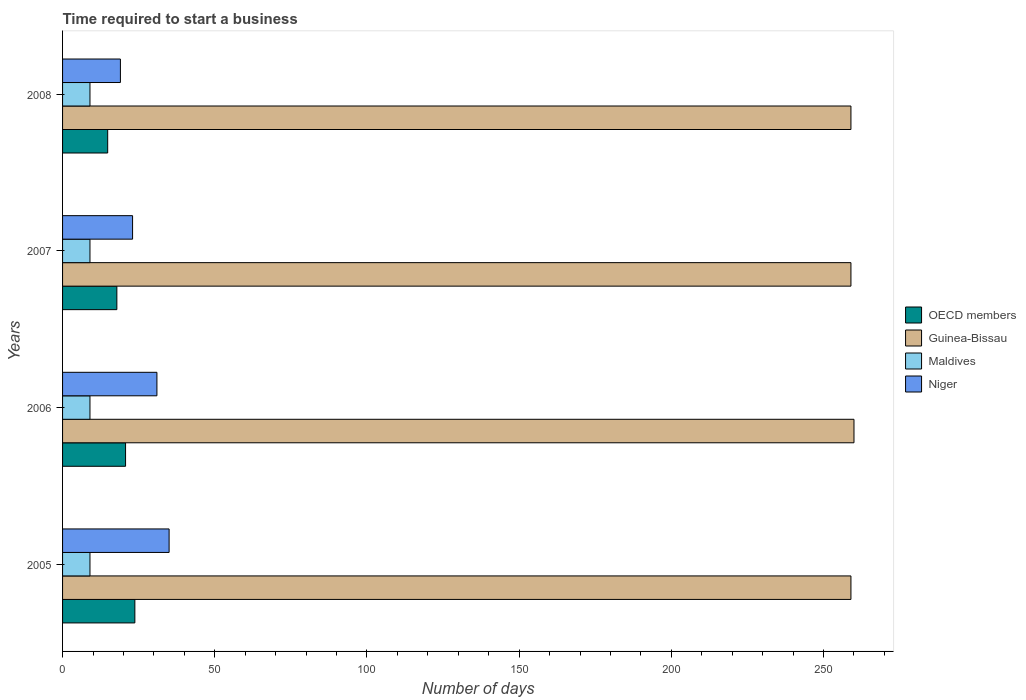How many groups of bars are there?
Provide a short and direct response. 4. Are the number of bars on each tick of the Y-axis equal?
Keep it short and to the point. Yes. How many bars are there on the 1st tick from the top?
Your answer should be compact. 4. What is the number of days required to start a business in Niger in 2008?
Your answer should be very brief. 19. Across all years, what is the maximum number of days required to start a business in OECD members?
Offer a terse response. 23.75. Across all years, what is the minimum number of days required to start a business in Niger?
Offer a very short reply. 19. In which year was the number of days required to start a business in Guinea-Bissau minimum?
Provide a succinct answer. 2005. What is the total number of days required to start a business in Maldives in the graph?
Your response must be concise. 36. What is the difference between the number of days required to start a business in Guinea-Bissau in 2005 and that in 2006?
Give a very brief answer. -1. What is the difference between the number of days required to start a business in Guinea-Bissau in 2005 and the number of days required to start a business in Maldives in 2008?
Provide a succinct answer. 250. In the year 2006, what is the difference between the number of days required to start a business in Niger and number of days required to start a business in Guinea-Bissau?
Your answer should be compact. -229. In how many years, is the number of days required to start a business in OECD members greater than 220 days?
Offer a terse response. 0. What is the ratio of the number of days required to start a business in Niger in 2006 to that in 2007?
Your answer should be compact. 1.35. What is the difference between the highest and the second highest number of days required to start a business in OECD members?
Offer a terse response. 3.06. Is it the case that in every year, the sum of the number of days required to start a business in Guinea-Bissau and number of days required to start a business in Niger is greater than the sum of number of days required to start a business in OECD members and number of days required to start a business in Maldives?
Offer a terse response. No. What does the 1st bar from the top in 2006 represents?
Offer a very short reply. Niger. What does the 3rd bar from the bottom in 2007 represents?
Give a very brief answer. Maldives. Is it the case that in every year, the sum of the number of days required to start a business in OECD members and number of days required to start a business in Maldives is greater than the number of days required to start a business in Guinea-Bissau?
Offer a very short reply. No. How many bars are there?
Your answer should be compact. 16. How many years are there in the graph?
Give a very brief answer. 4. Where does the legend appear in the graph?
Ensure brevity in your answer.  Center right. How are the legend labels stacked?
Keep it short and to the point. Vertical. What is the title of the graph?
Give a very brief answer. Time required to start a business. What is the label or title of the X-axis?
Offer a very short reply. Number of days. What is the Number of days in OECD members in 2005?
Your answer should be compact. 23.75. What is the Number of days of Guinea-Bissau in 2005?
Make the answer very short. 259. What is the Number of days in Maldives in 2005?
Offer a terse response. 9. What is the Number of days in OECD members in 2006?
Give a very brief answer. 20.69. What is the Number of days in Guinea-Bissau in 2006?
Make the answer very short. 260. What is the Number of days of Maldives in 2006?
Your answer should be compact. 9. What is the Number of days in OECD members in 2007?
Ensure brevity in your answer.  17.84. What is the Number of days in Guinea-Bissau in 2007?
Provide a short and direct response. 259. What is the Number of days of Niger in 2007?
Offer a very short reply. 23. What is the Number of days in OECD members in 2008?
Offer a terse response. 14.82. What is the Number of days in Guinea-Bissau in 2008?
Make the answer very short. 259. What is the Number of days of Maldives in 2008?
Keep it short and to the point. 9. What is the Number of days of Niger in 2008?
Make the answer very short. 19. Across all years, what is the maximum Number of days in OECD members?
Offer a terse response. 23.75. Across all years, what is the maximum Number of days in Guinea-Bissau?
Offer a terse response. 260. Across all years, what is the maximum Number of days of Niger?
Provide a succinct answer. 35. Across all years, what is the minimum Number of days of OECD members?
Give a very brief answer. 14.82. Across all years, what is the minimum Number of days of Guinea-Bissau?
Your response must be concise. 259. What is the total Number of days in OECD members in the graph?
Offer a very short reply. 77.1. What is the total Number of days in Guinea-Bissau in the graph?
Ensure brevity in your answer.  1037. What is the total Number of days in Niger in the graph?
Your response must be concise. 108. What is the difference between the Number of days in OECD members in 2005 and that in 2006?
Your answer should be very brief. 3.06. What is the difference between the Number of days of Guinea-Bissau in 2005 and that in 2006?
Keep it short and to the point. -1. What is the difference between the Number of days of Maldives in 2005 and that in 2006?
Provide a short and direct response. 0. What is the difference between the Number of days of Niger in 2005 and that in 2006?
Give a very brief answer. 4. What is the difference between the Number of days in OECD members in 2005 and that in 2007?
Provide a short and direct response. 5.91. What is the difference between the Number of days in Guinea-Bissau in 2005 and that in 2007?
Your response must be concise. 0. What is the difference between the Number of days in OECD members in 2005 and that in 2008?
Keep it short and to the point. 8.93. What is the difference between the Number of days in Guinea-Bissau in 2005 and that in 2008?
Provide a succinct answer. 0. What is the difference between the Number of days in Niger in 2005 and that in 2008?
Provide a short and direct response. 16. What is the difference between the Number of days of OECD members in 2006 and that in 2007?
Provide a short and direct response. 2.85. What is the difference between the Number of days of OECD members in 2006 and that in 2008?
Give a very brief answer. 5.87. What is the difference between the Number of days of OECD members in 2007 and that in 2008?
Provide a short and direct response. 3.02. What is the difference between the Number of days of Guinea-Bissau in 2007 and that in 2008?
Your answer should be compact. 0. What is the difference between the Number of days of OECD members in 2005 and the Number of days of Guinea-Bissau in 2006?
Provide a short and direct response. -236.25. What is the difference between the Number of days of OECD members in 2005 and the Number of days of Maldives in 2006?
Make the answer very short. 14.75. What is the difference between the Number of days of OECD members in 2005 and the Number of days of Niger in 2006?
Provide a short and direct response. -7.25. What is the difference between the Number of days of Guinea-Bissau in 2005 and the Number of days of Maldives in 2006?
Keep it short and to the point. 250. What is the difference between the Number of days in Guinea-Bissau in 2005 and the Number of days in Niger in 2006?
Provide a short and direct response. 228. What is the difference between the Number of days of OECD members in 2005 and the Number of days of Guinea-Bissau in 2007?
Your response must be concise. -235.25. What is the difference between the Number of days of OECD members in 2005 and the Number of days of Maldives in 2007?
Make the answer very short. 14.75. What is the difference between the Number of days in Guinea-Bissau in 2005 and the Number of days in Maldives in 2007?
Your response must be concise. 250. What is the difference between the Number of days of Guinea-Bissau in 2005 and the Number of days of Niger in 2007?
Give a very brief answer. 236. What is the difference between the Number of days of OECD members in 2005 and the Number of days of Guinea-Bissau in 2008?
Give a very brief answer. -235.25. What is the difference between the Number of days in OECD members in 2005 and the Number of days in Maldives in 2008?
Offer a terse response. 14.75. What is the difference between the Number of days of OECD members in 2005 and the Number of days of Niger in 2008?
Your response must be concise. 4.75. What is the difference between the Number of days in Guinea-Bissau in 2005 and the Number of days in Maldives in 2008?
Provide a succinct answer. 250. What is the difference between the Number of days of Guinea-Bissau in 2005 and the Number of days of Niger in 2008?
Make the answer very short. 240. What is the difference between the Number of days of Maldives in 2005 and the Number of days of Niger in 2008?
Your answer should be compact. -10. What is the difference between the Number of days of OECD members in 2006 and the Number of days of Guinea-Bissau in 2007?
Ensure brevity in your answer.  -238.31. What is the difference between the Number of days in OECD members in 2006 and the Number of days in Maldives in 2007?
Provide a short and direct response. 11.69. What is the difference between the Number of days of OECD members in 2006 and the Number of days of Niger in 2007?
Keep it short and to the point. -2.31. What is the difference between the Number of days in Guinea-Bissau in 2006 and the Number of days in Maldives in 2007?
Offer a terse response. 251. What is the difference between the Number of days in Guinea-Bissau in 2006 and the Number of days in Niger in 2007?
Your answer should be compact. 237. What is the difference between the Number of days in Maldives in 2006 and the Number of days in Niger in 2007?
Offer a terse response. -14. What is the difference between the Number of days of OECD members in 2006 and the Number of days of Guinea-Bissau in 2008?
Provide a succinct answer. -238.31. What is the difference between the Number of days of OECD members in 2006 and the Number of days of Maldives in 2008?
Your answer should be compact. 11.69. What is the difference between the Number of days of OECD members in 2006 and the Number of days of Niger in 2008?
Your answer should be very brief. 1.69. What is the difference between the Number of days of Guinea-Bissau in 2006 and the Number of days of Maldives in 2008?
Offer a terse response. 251. What is the difference between the Number of days in Guinea-Bissau in 2006 and the Number of days in Niger in 2008?
Your response must be concise. 241. What is the difference between the Number of days of Maldives in 2006 and the Number of days of Niger in 2008?
Your answer should be compact. -10. What is the difference between the Number of days in OECD members in 2007 and the Number of days in Guinea-Bissau in 2008?
Provide a succinct answer. -241.16. What is the difference between the Number of days of OECD members in 2007 and the Number of days of Maldives in 2008?
Give a very brief answer. 8.84. What is the difference between the Number of days in OECD members in 2007 and the Number of days in Niger in 2008?
Offer a very short reply. -1.16. What is the difference between the Number of days in Guinea-Bissau in 2007 and the Number of days in Maldives in 2008?
Your response must be concise. 250. What is the difference between the Number of days of Guinea-Bissau in 2007 and the Number of days of Niger in 2008?
Give a very brief answer. 240. What is the average Number of days of OECD members per year?
Give a very brief answer. 19.28. What is the average Number of days in Guinea-Bissau per year?
Your response must be concise. 259.25. What is the average Number of days in Maldives per year?
Your answer should be compact. 9. In the year 2005, what is the difference between the Number of days in OECD members and Number of days in Guinea-Bissau?
Make the answer very short. -235.25. In the year 2005, what is the difference between the Number of days in OECD members and Number of days in Maldives?
Ensure brevity in your answer.  14.75. In the year 2005, what is the difference between the Number of days in OECD members and Number of days in Niger?
Make the answer very short. -11.25. In the year 2005, what is the difference between the Number of days in Guinea-Bissau and Number of days in Maldives?
Give a very brief answer. 250. In the year 2005, what is the difference between the Number of days in Guinea-Bissau and Number of days in Niger?
Give a very brief answer. 224. In the year 2005, what is the difference between the Number of days in Maldives and Number of days in Niger?
Your response must be concise. -26. In the year 2006, what is the difference between the Number of days in OECD members and Number of days in Guinea-Bissau?
Ensure brevity in your answer.  -239.31. In the year 2006, what is the difference between the Number of days in OECD members and Number of days in Maldives?
Give a very brief answer. 11.69. In the year 2006, what is the difference between the Number of days in OECD members and Number of days in Niger?
Offer a very short reply. -10.31. In the year 2006, what is the difference between the Number of days in Guinea-Bissau and Number of days in Maldives?
Keep it short and to the point. 251. In the year 2006, what is the difference between the Number of days of Guinea-Bissau and Number of days of Niger?
Your response must be concise. 229. In the year 2007, what is the difference between the Number of days in OECD members and Number of days in Guinea-Bissau?
Provide a short and direct response. -241.16. In the year 2007, what is the difference between the Number of days of OECD members and Number of days of Maldives?
Make the answer very short. 8.84. In the year 2007, what is the difference between the Number of days in OECD members and Number of days in Niger?
Make the answer very short. -5.16. In the year 2007, what is the difference between the Number of days in Guinea-Bissau and Number of days in Maldives?
Provide a short and direct response. 250. In the year 2007, what is the difference between the Number of days of Guinea-Bissau and Number of days of Niger?
Offer a very short reply. 236. In the year 2008, what is the difference between the Number of days of OECD members and Number of days of Guinea-Bissau?
Offer a very short reply. -244.18. In the year 2008, what is the difference between the Number of days of OECD members and Number of days of Maldives?
Ensure brevity in your answer.  5.82. In the year 2008, what is the difference between the Number of days in OECD members and Number of days in Niger?
Provide a succinct answer. -4.18. In the year 2008, what is the difference between the Number of days of Guinea-Bissau and Number of days of Maldives?
Provide a short and direct response. 250. In the year 2008, what is the difference between the Number of days of Guinea-Bissau and Number of days of Niger?
Your answer should be very brief. 240. In the year 2008, what is the difference between the Number of days of Maldives and Number of days of Niger?
Provide a short and direct response. -10. What is the ratio of the Number of days of OECD members in 2005 to that in 2006?
Offer a very short reply. 1.15. What is the ratio of the Number of days of Guinea-Bissau in 2005 to that in 2006?
Give a very brief answer. 1. What is the ratio of the Number of days in Niger in 2005 to that in 2006?
Offer a very short reply. 1.13. What is the ratio of the Number of days of OECD members in 2005 to that in 2007?
Provide a short and direct response. 1.33. What is the ratio of the Number of days of Guinea-Bissau in 2005 to that in 2007?
Your answer should be very brief. 1. What is the ratio of the Number of days of Niger in 2005 to that in 2007?
Your answer should be very brief. 1.52. What is the ratio of the Number of days in OECD members in 2005 to that in 2008?
Keep it short and to the point. 1.6. What is the ratio of the Number of days in Maldives in 2005 to that in 2008?
Offer a terse response. 1. What is the ratio of the Number of days of Niger in 2005 to that in 2008?
Your response must be concise. 1.84. What is the ratio of the Number of days in OECD members in 2006 to that in 2007?
Make the answer very short. 1.16. What is the ratio of the Number of days of Guinea-Bissau in 2006 to that in 2007?
Your response must be concise. 1. What is the ratio of the Number of days in Maldives in 2006 to that in 2007?
Your answer should be very brief. 1. What is the ratio of the Number of days in Niger in 2006 to that in 2007?
Ensure brevity in your answer.  1.35. What is the ratio of the Number of days in OECD members in 2006 to that in 2008?
Your response must be concise. 1.4. What is the ratio of the Number of days of Maldives in 2006 to that in 2008?
Keep it short and to the point. 1. What is the ratio of the Number of days in Niger in 2006 to that in 2008?
Provide a short and direct response. 1.63. What is the ratio of the Number of days of OECD members in 2007 to that in 2008?
Provide a short and direct response. 1.2. What is the ratio of the Number of days in Guinea-Bissau in 2007 to that in 2008?
Offer a very short reply. 1. What is the ratio of the Number of days in Niger in 2007 to that in 2008?
Offer a terse response. 1.21. What is the difference between the highest and the second highest Number of days in OECD members?
Keep it short and to the point. 3.06. What is the difference between the highest and the second highest Number of days in Guinea-Bissau?
Provide a short and direct response. 1. What is the difference between the highest and the second highest Number of days of Maldives?
Keep it short and to the point. 0. What is the difference between the highest and the second highest Number of days in Niger?
Give a very brief answer. 4. What is the difference between the highest and the lowest Number of days in OECD members?
Your response must be concise. 8.93. What is the difference between the highest and the lowest Number of days in Niger?
Offer a terse response. 16. 